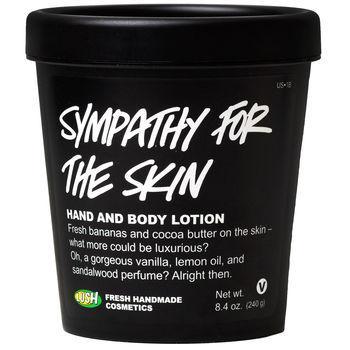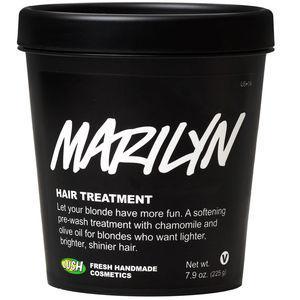The first image is the image on the left, the second image is the image on the right. Examine the images to the left and right. Is the description "In one image, the top is on the black tub, and in the other it is off, revealing a white cream inside" accurate? Answer yes or no. No. The first image is the image on the left, the second image is the image on the right. For the images displayed, is the sentence "A lid is leaning next to one of the black tubs." factually correct? Answer yes or no. No. 